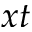<formula> <loc_0><loc_0><loc_500><loc_500>x t</formula> 